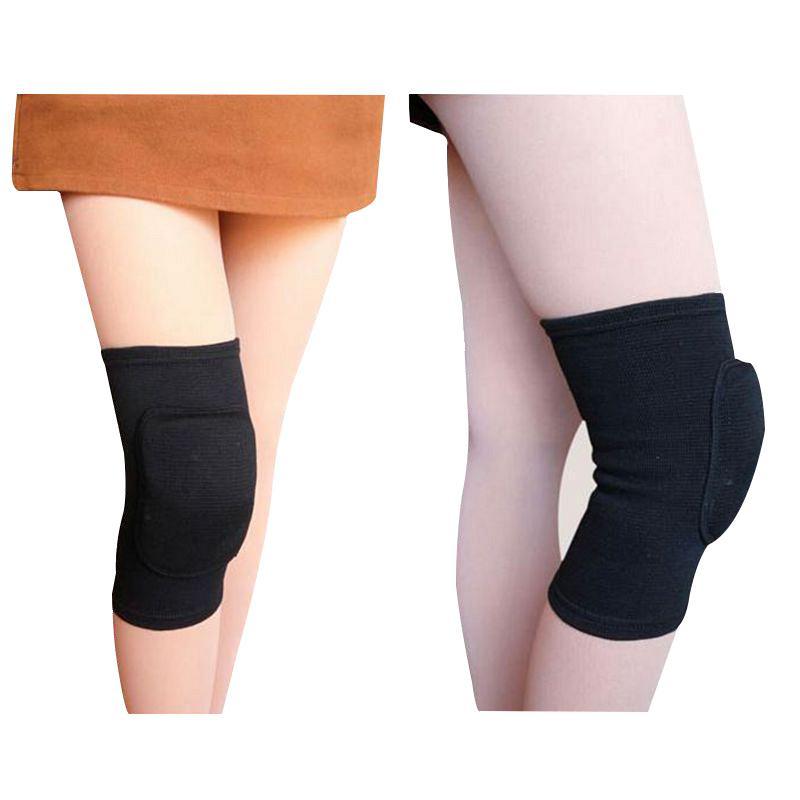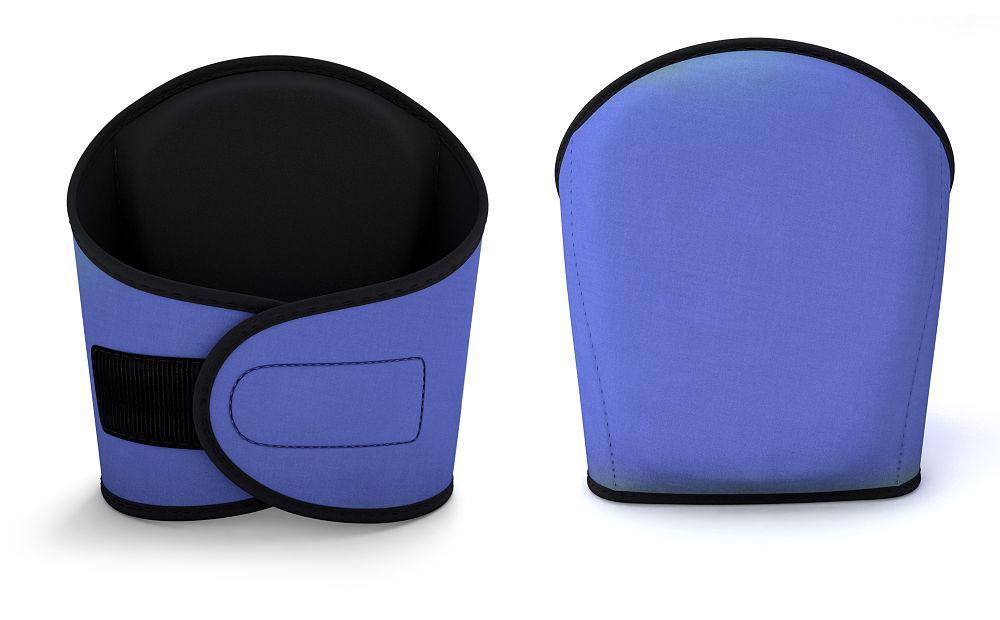The first image is the image on the left, the second image is the image on the right. Analyze the images presented: Is the assertion "Each image includes a rightward-bent knee in a hot pink knee pad." valid? Answer yes or no. No. 